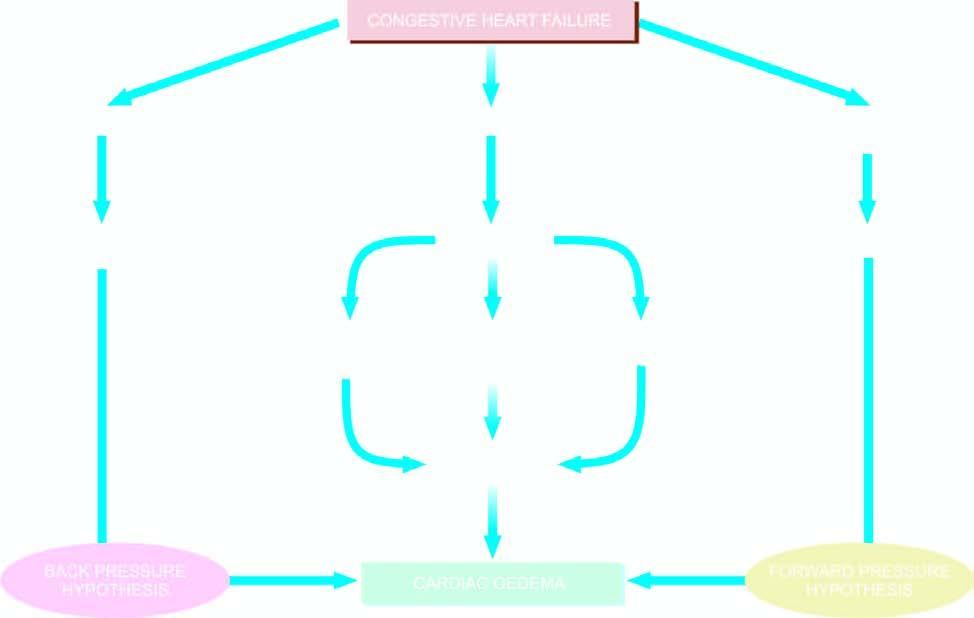what is mechanisms involved in?
Answer the question using a single word or phrase. Oedema 